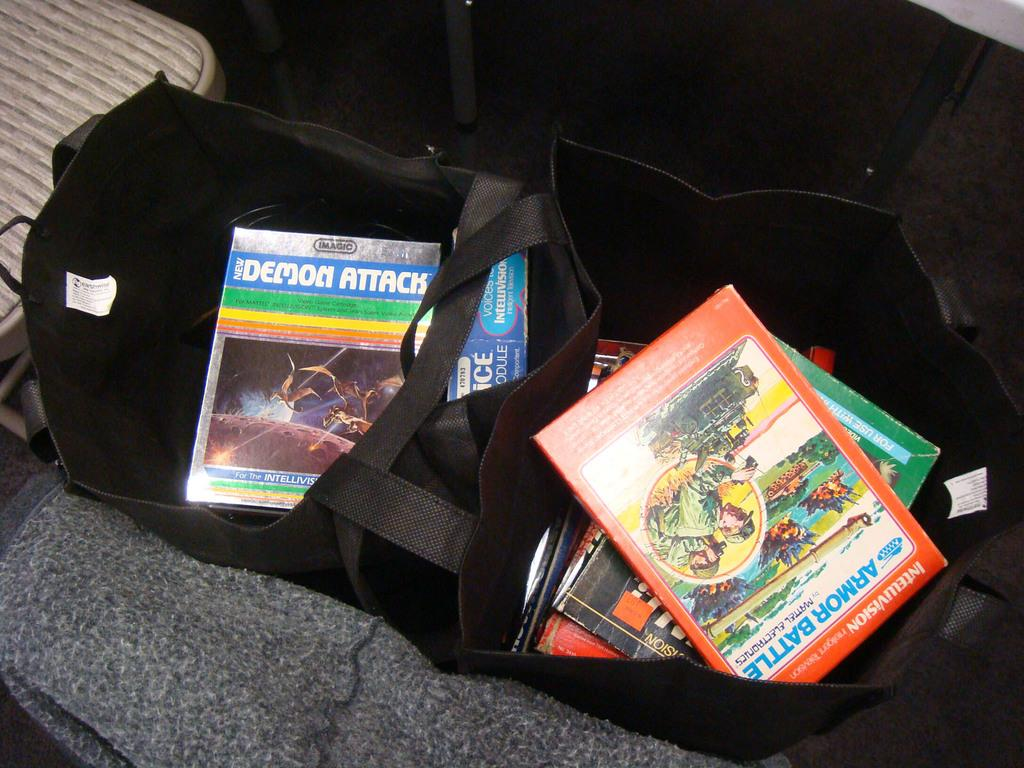<image>
Write a terse but informative summary of the picture. An open tote bag has a copy of the Demon Attack game in it. 